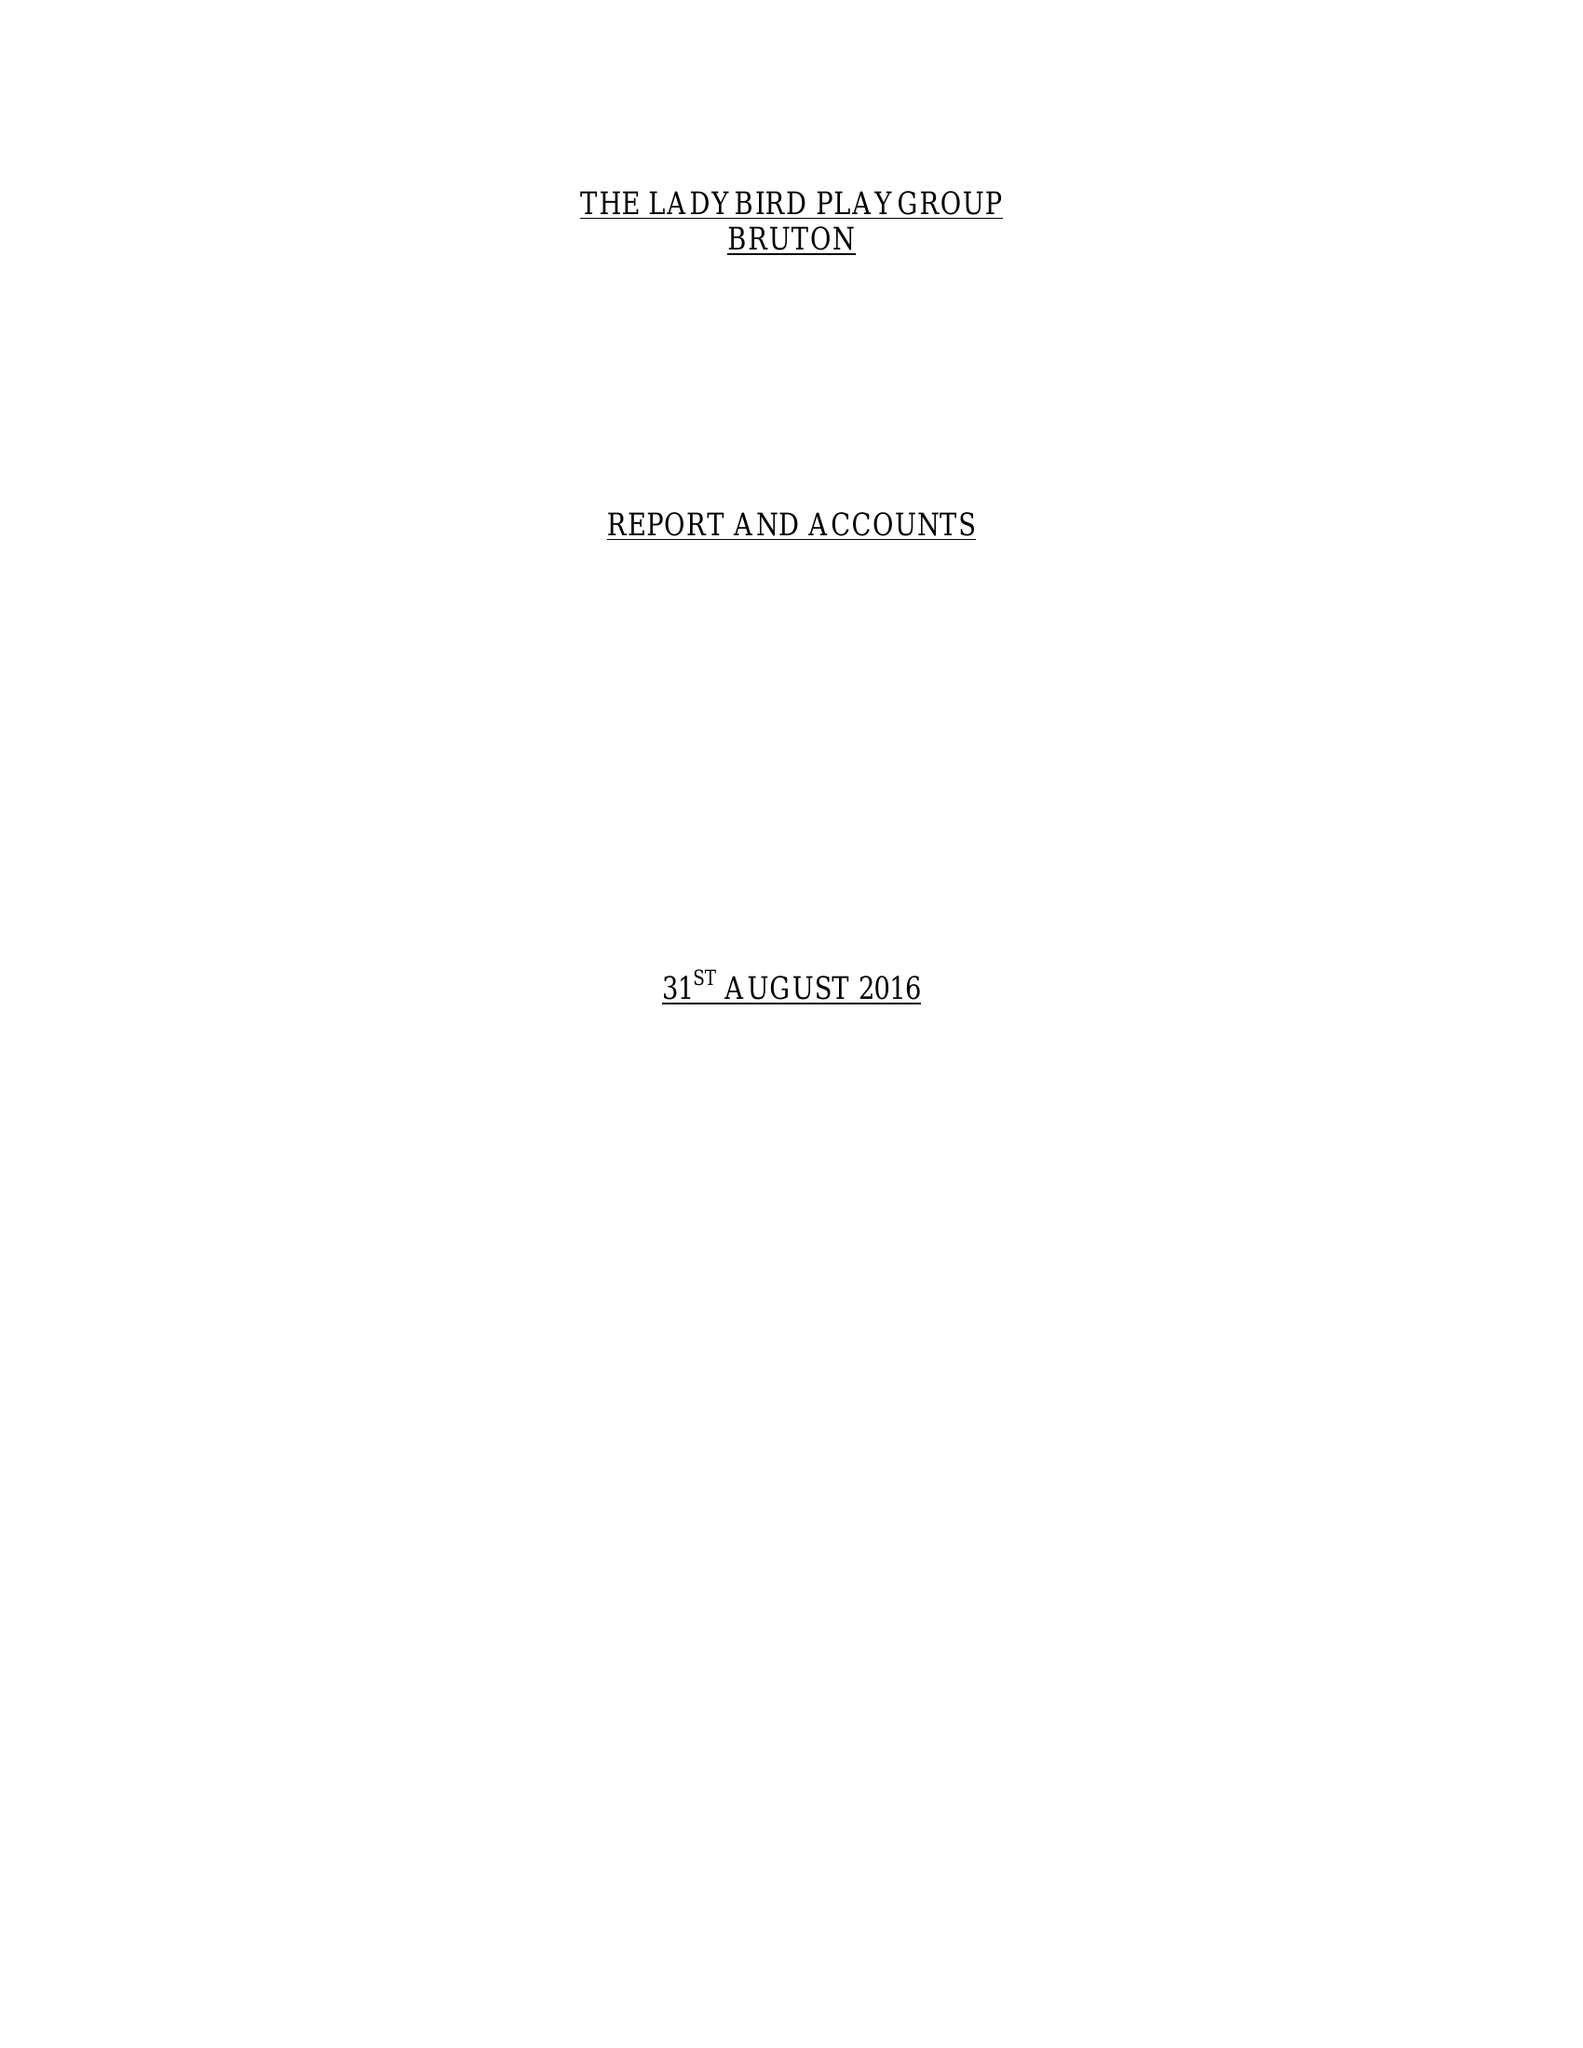What is the value for the income_annually_in_british_pounds?
Answer the question using a single word or phrase. 64515.00 